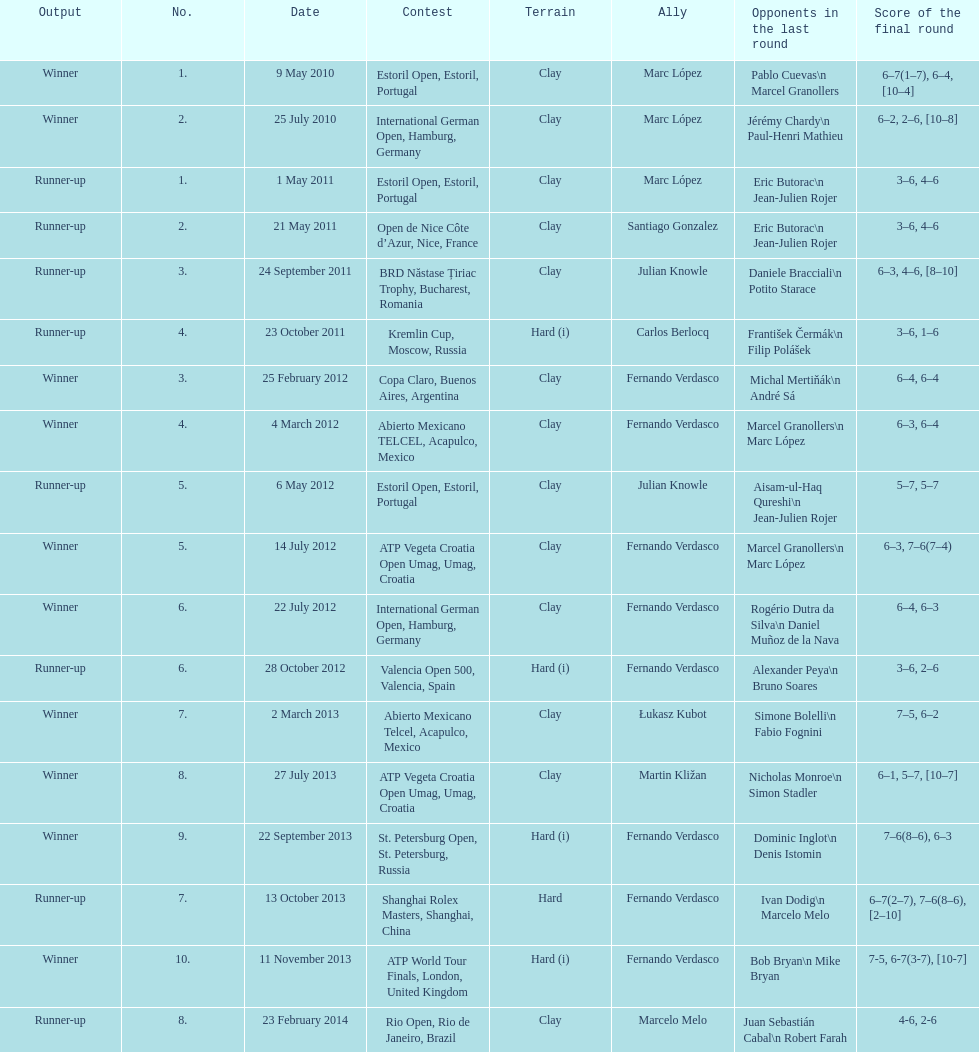What is the total number of runner-ups listed on the chart? 8. 